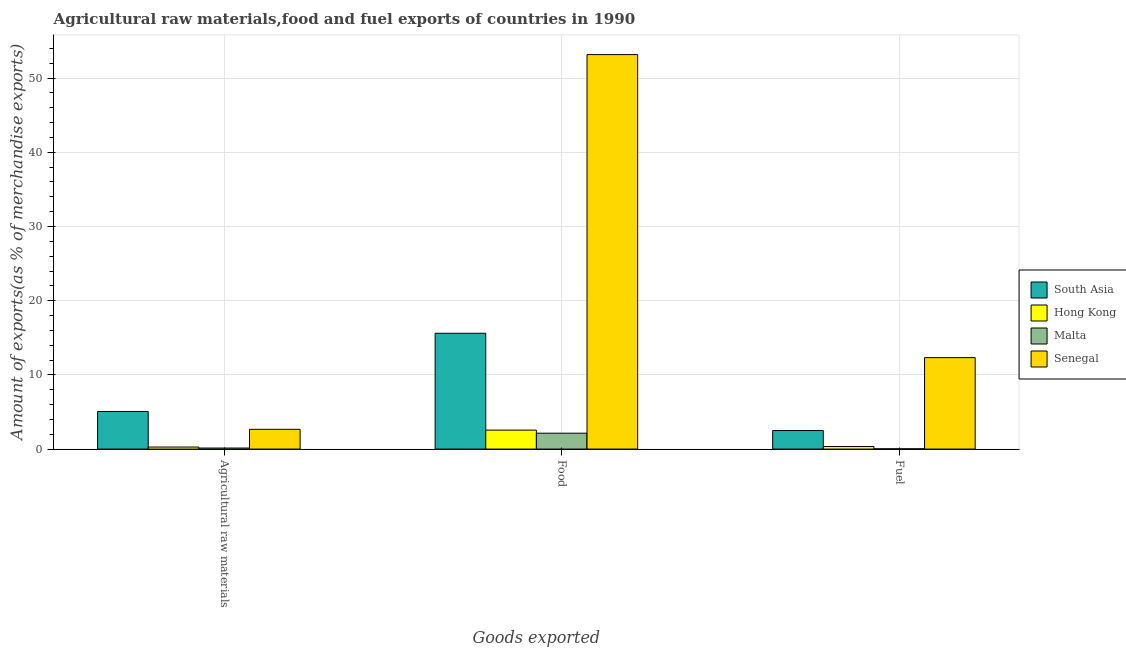Are the number of bars per tick equal to the number of legend labels?
Your response must be concise. Yes. How many bars are there on the 2nd tick from the left?
Give a very brief answer. 4. How many bars are there on the 2nd tick from the right?
Provide a short and direct response. 4. What is the label of the 1st group of bars from the left?
Provide a succinct answer. Agricultural raw materials. What is the percentage of fuel exports in South Asia?
Your answer should be very brief. 2.5. Across all countries, what is the maximum percentage of raw materials exports?
Provide a short and direct response. 5.07. Across all countries, what is the minimum percentage of food exports?
Provide a short and direct response. 2.14. In which country was the percentage of raw materials exports maximum?
Make the answer very short. South Asia. In which country was the percentage of fuel exports minimum?
Provide a succinct answer. Malta. What is the total percentage of fuel exports in the graph?
Ensure brevity in your answer.  15.21. What is the difference between the percentage of fuel exports in Malta and that in South Asia?
Offer a very short reply. -2.46. What is the difference between the percentage of raw materials exports in Malta and the percentage of food exports in Senegal?
Your answer should be compact. -53.03. What is the average percentage of food exports per country?
Ensure brevity in your answer.  18.37. What is the difference between the percentage of fuel exports and percentage of food exports in Hong Kong?
Make the answer very short. -2.21. In how many countries, is the percentage of raw materials exports greater than 6 %?
Provide a short and direct response. 0. What is the ratio of the percentage of raw materials exports in South Asia to that in Hong Kong?
Provide a short and direct response. 18.44. What is the difference between the highest and the second highest percentage of fuel exports?
Provide a succinct answer. 9.83. What is the difference between the highest and the lowest percentage of fuel exports?
Your answer should be very brief. 12.29. Is the sum of the percentage of food exports in Hong Kong and Malta greater than the maximum percentage of raw materials exports across all countries?
Ensure brevity in your answer.  No. What does the 1st bar from the left in Food represents?
Give a very brief answer. South Asia. Is it the case that in every country, the sum of the percentage of raw materials exports and percentage of food exports is greater than the percentage of fuel exports?
Give a very brief answer. Yes. How many bars are there?
Ensure brevity in your answer.  12. Are all the bars in the graph horizontal?
Provide a short and direct response. No. What is the difference between two consecutive major ticks on the Y-axis?
Keep it short and to the point. 10. Are the values on the major ticks of Y-axis written in scientific E-notation?
Your answer should be compact. No. How many legend labels are there?
Provide a succinct answer. 4. How are the legend labels stacked?
Provide a succinct answer. Vertical. What is the title of the graph?
Ensure brevity in your answer.  Agricultural raw materials,food and fuel exports of countries in 1990. What is the label or title of the X-axis?
Provide a short and direct response. Goods exported. What is the label or title of the Y-axis?
Offer a very short reply. Amount of exports(as % of merchandise exports). What is the Amount of exports(as % of merchandise exports) in South Asia in Agricultural raw materials?
Give a very brief answer. 5.07. What is the Amount of exports(as % of merchandise exports) in Hong Kong in Agricultural raw materials?
Your response must be concise. 0.27. What is the Amount of exports(as % of merchandise exports) of Malta in Agricultural raw materials?
Make the answer very short. 0.14. What is the Amount of exports(as % of merchandise exports) of Senegal in Agricultural raw materials?
Ensure brevity in your answer.  2.66. What is the Amount of exports(as % of merchandise exports) in South Asia in Food?
Give a very brief answer. 15.61. What is the Amount of exports(as % of merchandise exports) of Hong Kong in Food?
Provide a succinct answer. 2.56. What is the Amount of exports(as % of merchandise exports) in Malta in Food?
Provide a short and direct response. 2.14. What is the Amount of exports(as % of merchandise exports) in Senegal in Food?
Give a very brief answer. 53.17. What is the Amount of exports(as % of merchandise exports) in South Asia in Fuel?
Provide a short and direct response. 2.5. What is the Amount of exports(as % of merchandise exports) in Hong Kong in Fuel?
Your response must be concise. 0.35. What is the Amount of exports(as % of merchandise exports) in Malta in Fuel?
Your answer should be very brief. 0.03. What is the Amount of exports(as % of merchandise exports) of Senegal in Fuel?
Your answer should be compact. 12.33. Across all Goods exported, what is the maximum Amount of exports(as % of merchandise exports) in South Asia?
Your response must be concise. 15.61. Across all Goods exported, what is the maximum Amount of exports(as % of merchandise exports) in Hong Kong?
Provide a succinct answer. 2.56. Across all Goods exported, what is the maximum Amount of exports(as % of merchandise exports) in Malta?
Offer a terse response. 2.14. Across all Goods exported, what is the maximum Amount of exports(as % of merchandise exports) of Senegal?
Your answer should be very brief. 53.17. Across all Goods exported, what is the minimum Amount of exports(as % of merchandise exports) in South Asia?
Give a very brief answer. 2.5. Across all Goods exported, what is the minimum Amount of exports(as % of merchandise exports) in Hong Kong?
Keep it short and to the point. 0.27. Across all Goods exported, what is the minimum Amount of exports(as % of merchandise exports) of Malta?
Offer a terse response. 0.03. Across all Goods exported, what is the minimum Amount of exports(as % of merchandise exports) of Senegal?
Ensure brevity in your answer.  2.66. What is the total Amount of exports(as % of merchandise exports) in South Asia in the graph?
Offer a very short reply. 23.18. What is the total Amount of exports(as % of merchandise exports) in Hong Kong in the graph?
Make the answer very short. 3.18. What is the total Amount of exports(as % of merchandise exports) of Malta in the graph?
Ensure brevity in your answer.  2.31. What is the total Amount of exports(as % of merchandise exports) in Senegal in the graph?
Ensure brevity in your answer.  68.16. What is the difference between the Amount of exports(as % of merchandise exports) of South Asia in Agricultural raw materials and that in Food?
Ensure brevity in your answer.  -10.54. What is the difference between the Amount of exports(as % of merchandise exports) in Hong Kong in Agricultural raw materials and that in Food?
Your answer should be compact. -2.28. What is the difference between the Amount of exports(as % of merchandise exports) of Malta in Agricultural raw materials and that in Food?
Ensure brevity in your answer.  -2. What is the difference between the Amount of exports(as % of merchandise exports) of Senegal in Agricultural raw materials and that in Food?
Offer a terse response. -50.51. What is the difference between the Amount of exports(as % of merchandise exports) of South Asia in Agricultural raw materials and that in Fuel?
Ensure brevity in your answer.  2.57. What is the difference between the Amount of exports(as % of merchandise exports) of Hong Kong in Agricultural raw materials and that in Fuel?
Your answer should be compact. -0.07. What is the difference between the Amount of exports(as % of merchandise exports) of Malta in Agricultural raw materials and that in Fuel?
Your response must be concise. 0.1. What is the difference between the Amount of exports(as % of merchandise exports) of Senegal in Agricultural raw materials and that in Fuel?
Offer a terse response. -9.66. What is the difference between the Amount of exports(as % of merchandise exports) in South Asia in Food and that in Fuel?
Offer a terse response. 13.11. What is the difference between the Amount of exports(as % of merchandise exports) of Hong Kong in Food and that in Fuel?
Your response must be concise. 2.21. What is the difference between the Amount of exports(as % of merchandise exports) in Malta in Food and that in Fuel?
Your answer should be very brief. 2.11. What is the difference between the Amount of exports(as % of merchandise exports) of Senegal in Food and that in Fuel?
Ensure brevity in your answer.  40.84. What is the difference between the Amount of exports(as % of merchandise exports) of South Asia in Agricultural raw materials and the Amount of exports(as % of merchandise exports) of Hong Kong in Food?
Offer a very short reply. 2.51. What is the difference between the Amount of exports(as % of merchandise exports) in South Asia in Agricultural raw materials and the Amount of exports(as % of merchandise exports) in Malta in Food?
Provide a short and direct response. 2.93. What is the difference between the Amount of exports(as % of merchandise exports) in South Asia in Agricultural raw materials and the Amount of exports(as % of merchandise exports) in Senegal in Food?
Provide a short and direct response. -48.1. What is the difference between the Amount of exports(as % of merchandise exports) of Hong Kong in Agricultural raw materials and the Amount of exports(as % of merchandise exports) of Malta in Food?
Your answer should be very brief. -1.86. What is the difference between the Amount of exports(as % of merchandise exports) of Hong Kong in Agricultural raw materials and the Amount of exports(as % of merchandise exports) of Senegal in Food?
Provide a short and direct response. -52.9. What is the difference between the Amount of exports(as % of merchandise exports) of Malta in Agricultural raw materials and the Amount of exports(as % of merchandise exports) of Senegal in Food?
Make the answer very short. -53.03. What is the difference between the Amount of exports(as % of merchandise exports) of South Asia in Agricultural raw materials and the Amount of exports(as % of merchandise exports) of Hong Kong in Fuel?
Make the answer very short. 4.73. What is the difference between the Amount of exports(as % of merchandise exports) of South Asia in Agricultural raw materials and the Amount of exports(as % of merchandise exports) of Malta in Fuel?
Give a very brief answer. 5.04. What is the difference between the Amount of exports(as % of merchandise exports) in South Asia in Agricultural raw materials and the Amount of exports(as % of merchandise exports) in Senegal in Fuel?
Your response must be concise. -7.26. What is the difference between the Amount of exports(as % of merchandise exports) of Hong Kong in Agricultural raw materials and the Amount of exports(as % of merchandise exports) of Malta in Fuel?
Your answer should be compact. 0.24. What is the difference between the Amount of exports(as % of merchandise exports) of Hong Kong in Agricultural raw materials and the Amount of exports(as % of merchandise exports) of Senegal in Fuel?
Ensure brevity in your answer.  -12.05. What is the difference between the Amount of exports(as % of merchandise exports) of Malta in Agricultural raw materials and the Amount of exports(as % of merchandise exports) of Senegal in Fuel?
Make the answer very short. -12.19. What is the difference between the Amount of exports(as % of merchandise exports) in South Asia in Food and the Amount of exports(as % of merchandise exports) in Hong Kong in Fuel?
Keep it short and to the point. 15.27. What is the difference between the Amount of exports(as % of merchandise exports) of South Asia in Food and the Amount of exports(as % of merchandise exports) of Malta in Fuel?
Offer a terse response. 15.58. What is the difference between the Amount of exports(as % of merchandise exports) in South Asia in Food and the Amount of exports(as % of merchandise exports) in Senegal in Fuel?
Make the answer very short. 3.28. What is the difference between the Amount of exports(as % of merchandise exports) of Hong Kong in Food and the Amount of exports(as % of merchandise exports) of Malta in Fuel?
Your response must be concise. 2.52. What is the difference between the Amount of exports(as % of merchandise exports) of Hong Kong in Food and the Amount of exports(as % of merchandise exports) of Senegal in Fuel?
Your answer should be very brief. -9.77. What is the difference between the Amount of exports(as % of merchandise exports) in Malta in Food and the Amount of exports(as % of merchandise exports) in Senegal in Fuel?
Provide a succinct answer. -10.19. What is the average Amount of exports(as % of merchandise exports) of South Asia per Goods exported?
Offer a very short reply. 7.73. What is the average Amount of exports(as % of merchandise exports) in Hong Kong per Goods exported?
Make the answer very short. 1.06. What is the average Amount of exports(as % of merchandise exports) of Malta per Goods exported?
Your answer should be compact. 0.77. What is the average Amount of exports(as % of merchandise exports) in Senegal per Goods exported?
Keep it short and to the point. 22.72. What is the difference between the Amount of exports(as % of merchandise exports) in South Asia and Amount of exports(as % of merchandise exports) in Hong Kong in Agricultural raw materials?
Give a very brief answer. 4.8. What is the difference between the Amount of exports(as % of merchandise exports) of South Asia and Amount of exports(as % of merchandise exports) of Malta in Agricultural raw materials?
Provide a short and direct response. 4.93. What is the difference between the Amount of exports(as % of merchandise exports) of South Asia and Amount of exports(as % of merchandise exports) of Senegal in Agricultural raw materials?
Provide a succinct answer. 2.41. What is the difference between the Amount of exports(as % of merchandise exports) of Hong Kong and Amount of exports(as % of merchandise exports) of Malta in Agricultural raw materials?
Make the answer very short. 0.14. What is the difference between the Amount of exports(as % of merchandise exports) in Hong Kong and Amount of exports(as % of merchandise exports) in Senegal in Agricultural raw materials?
Make the answer very short. -2.39. What is the difference between the Amount of exports(as % of merchandise exports) in Malta and Amount of exports(as % of merchandise exports) in Senegal in Agricultural raw materials?
Provide a short and direct response. -2.52. What is the difference between the Amount of exports(as % of merchandise exports) in South Asia and Amount of exports(as % of merchandise exports) in Hong Kong in Food?
Give a very brief answer. 13.06. What is the difference between the Amount of exports(as % of merchandise exports) in South Asia and Amount of exports(as % of merchandise exports) in Malta in Food?
Offer a very short reply. 13.47. What is the difference between the Amount of exports(as % of merchandise exports) in South Asia and Amount of exports(as % of merchandise exports) in Senegal in Food?
Offer a terse response. -37.56. What is the difference between the Amount of exports(as % of merchandise exports) in Hong Kong and Amount of exports(as % of merchandise exports) in Malta in Food?
Provide a short and direct response. 0.42. What is the difference between the Amount of exports(as % of merchandise exports) in Hong Kong and Amount of exports(as % of merchandise exports) in Senegal in Food?
Offer a very short reply. -50.61. What is the difference between the Amount of exports(as % of merchandise exports) of Malta and Amount of exports(as % of merchandise exports) of Senegal in Food?
Ensure brevity in your answer.  -51.03. What is the difference between the Amount of exports(as % of merchandise exports) in South Asia and Amount of exports(as % of merchandise exports) in Hong Kong in Fuel?
Offer a very short reply. 2.15. What is the difference between the Amount of exports(as % of merchandise exports) in South Asia and Amount of exports(as % of merchandise exports) in Malta in Fuel?
Provide a short and direct response. 2.46. What is the difference between the Amount of exports(as % of merchandise exports) in South Asia and Amount of exports(as % of merchandise exports) in Senegal in Fuel?
Your answer should be very brief. -9.83. What is the difference between the Amount of exports(as % of merchandise exports) of Hong Kong and Amount of exports(as % of merchandise exports) of Malta in Fuel?
Make the answer very short. 0.31. What is the difference between the Amount of exports(as % of merchandise exports) of Hong Kong and Amount of exports(as % of merchandise exports) of Senegal in Fuel?
Offer a terse response. -11.98. What is the difference between the Amount of exports(as % of merchandise exports) in Malta and Amount of exports(as % of merchandise exports) in Senegal in Fuel?
Ensure brevity in your answer.  -12.29. What is the ratio of the Amount of exports(as % of merchandise exports) in South Asia in Agricultural raw materials to that in Food?
Keep it short and to the point. 0.32. What is the ratio of the Amount of exports(as % of merchandise exports) of Hong Kong in Agricultural raw materials to that in Food?
Your answer should be very brief. 0.11. What is the ratio of the Amount of exports(as % of merchandise exports) of Malta in Agricultural raw materials to that in Food?
Ensure brevity in your answer.  0.07. What is the ratio of the Amount of exports(as % of merchandise exports) of Senegal in Agricultural raw materials to that in Food?
Provide a succinct answer. 0.05. What is the ratio of the Amount of exports(as % of merchandise exports) in South Asia in Agricultural raw materials to that in Fuel?
Provide a short and direct response. 2.03. What is the ratio of the Amount of exports(as % of merchandise exports) of Hong Kong in Agricultural raw materials to that in Fuel?
Provide a succinct answer. 0.8. What is the ratio of the Amount of exports(as % of merchandise exports) of Malta in Agricultural raw materials to that in Fuel?
Offer a terse response. 4.03. What is the ratio of the Amount of exports(as % of merchandise exports) in Senegal in Agricultural raw materials to that in Fuel?
Your answer should be compact. 0.22. What is the ratio of the Amount of exports(as % of merchandise exports) of South Asia in Food to that in Fuel?
Provide a succinct answer. 6.25. What is the ratio of the Amount of exports(as % of merchandise exports) in Hong Kong in Food to that in Fuel?
Ensure brevity in your answer.  7.4. What is the ratio of the Amount of exports(as % of merchandise exports) of Malta in Food to that in Fuel?
Offer a terse response. 62. What is the ratio of the Amount of exports(as % of merchandise exports) in Senegal in Food to that in Fuel?
Make the answer very short. 4.31. What is the difference between the highest and the second highest Amount of exports(as % of merchandise exports) in South Asia?
Ensure brevity in your answer.  10.54. What is the difference between the highest and the second highest Amount of exports(as % of merchandise exports) in Hong Kong?
Give a very brief answer. 2.21. What is the difference between the highest and the second highest Amount of exports(as % of merchandise exports) in Malta?
Offer a terse response. 2. What is the difference between the highest and the second highest Amount of exports(as % of merchandise exports) in Senegal?
Provide a succinct answer. 40.84. What is the difference between the highest and the lowest Amount of exports(as % of merchandise exports) of South Asia?
Ensure brevity in your answer.  13.11. What is the difference between the highest and the lowest Amount of exports(as % of merchandise exports) of Hong Kong?
Offer a terse response. 2.28. What is the difference between the highest and the lowest Amount of exports(as % of merchandise exports) in Malta?
Make the answer very short. 2.11. What is the difference between the highest and the lowest Amount of exports(as % of merchandise exports) in Senegal?
Offer a terse response. 50.51. 